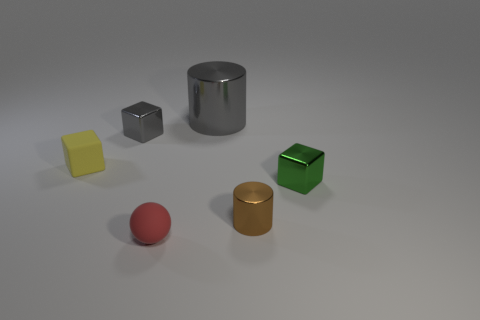Subtract all shiny cubes. How many cubes are left? 1 Add 2 red things. How many objects exist? 8 Subtract all gray cubes. How many cubes are left? 2 Subtract 1 spheres. How many spheres are left? 0 Add 6 big metal things. How many big metal things are left? 7 Add 3 yellow things. How many yellow things exist? 4 Subtract 0 purple cylinders. How many objects are left? 6 Subtract all balls. How many objects are left? 5 Subtract all purple blocks. Subtract all cyan balls. How many blocks are left? 3 Subtract all small red rubber balls. Subtract all tiny yellow rubber things. How many objects are left? 4 